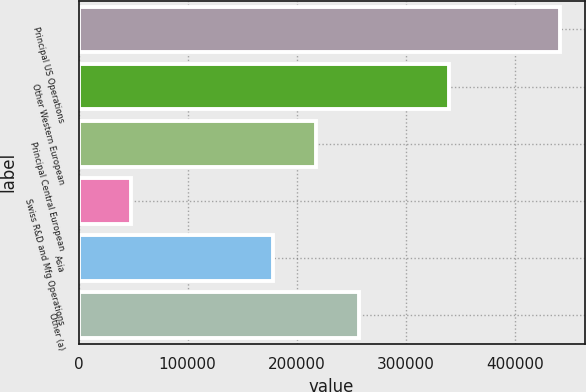<chart> <loc_0><loc_0><loc_500><loc_500><bar_chart><fcel>Principal US Operations<fcel>Other Western European<fcel>Principal Central European<fcel>Swiss R&D and Mfg Operations<fcel>Asia<fcel>Other (a)<nl><fcel>441707<fcel>339807<fcel>217724<fcel>47582<fcel>178311<fcel>257136<nl></chart> 